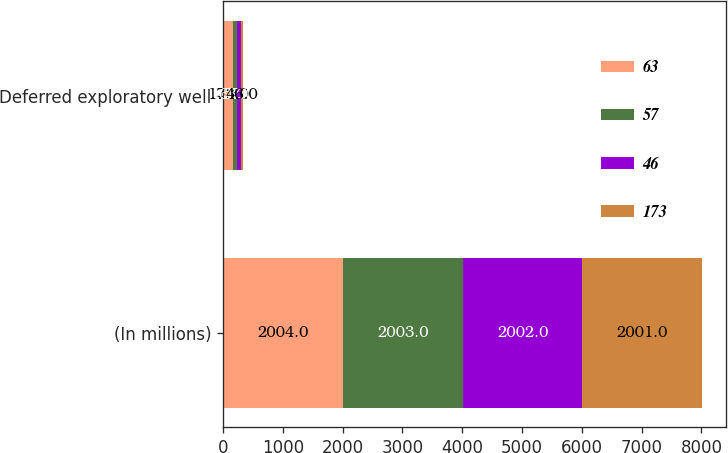<chart> <loc_0><loc_0><loc_500><loc_500><stacked_bar_chart><ecel><fcel>(In millions)<fcel>Deferred exploratory well<nl><fcel>63<fcel>2004<fcel>173<nl><fcel>57<fcel>2003<fcel>63<nl><fcel>46<fcel>2002<fcel>57<nl><fcel>173<fcel>2001<fcel>46<nl></chart> 